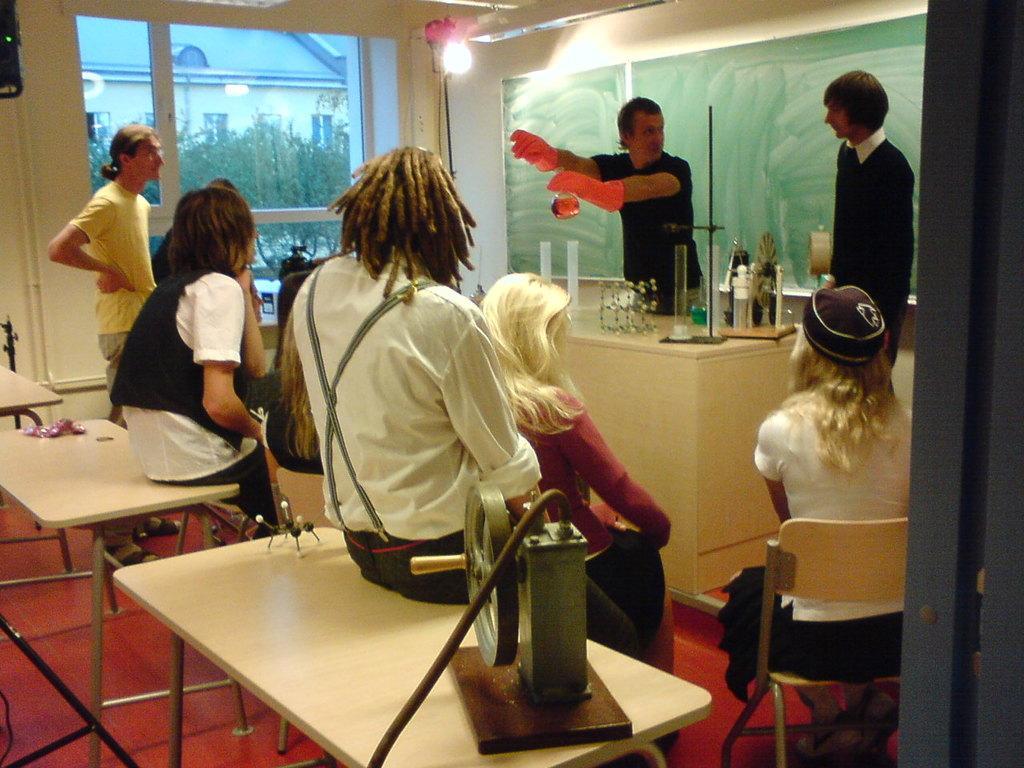In one or two sentences, can you explain what this image depicts? The picture is taken in a closed room and at the right corner of the picture one person is standing and one woman is sitting and she is a wearing a cap and white shirt and at the left corner of the picture on person is standing in yellow shirt and behind him there is a big window and outside of the window there are trees and building and in the middle of the picture one person is wearing black shirt and orange gloves and one bottle in his hand and behind him there is a green board and in the middle of the picture on the table there is one instrument and there are some tubes and glasses are present. 